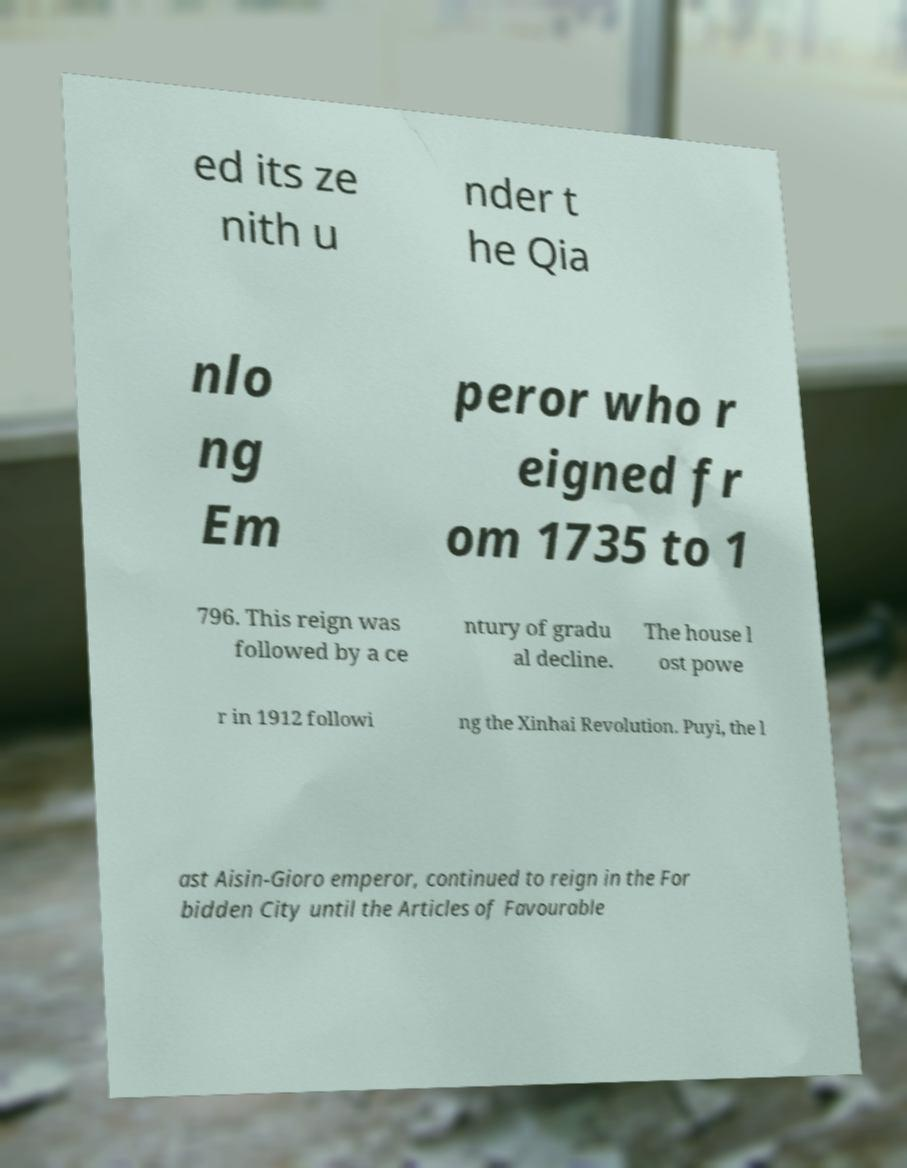What messages or text are displayed in this image? I need them in a readable, typed format. ed its ze nith u nder t he Qia nlo ng Em peror who r eigned fr om 1735 to 1 796. This reign was followed by a ce ntury of gradu al decline. The house l ost powe r in 1912 followi ng the Xinhai Revolution. Puyi, the l ast Aisin-Gioro emperor, continued to reign in the For bidden City until the Articles of Favourable 